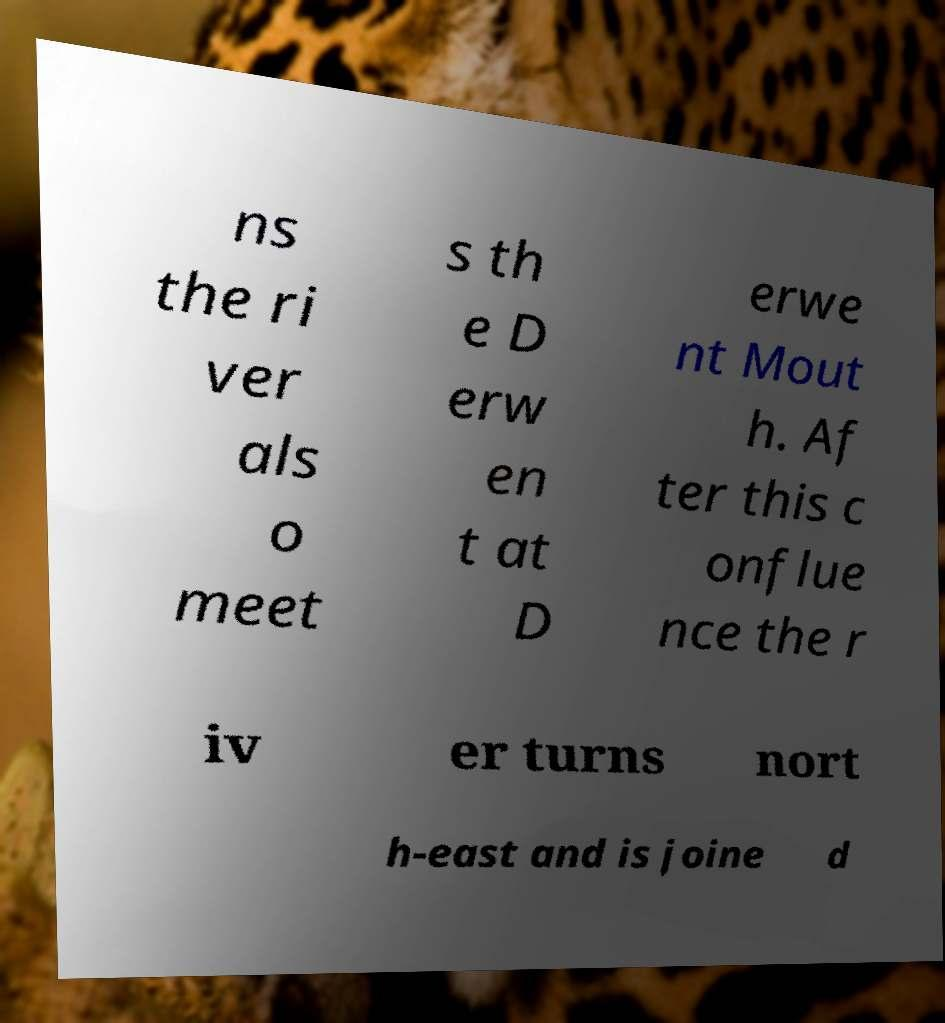Can you accurately transcribe the text from the provided image for me? ns the ri ver als o meet s th e D erw en t at D erwe nt Mout h. Af ter this c onflue nce the r iv er turns nort h-east and is joine d 